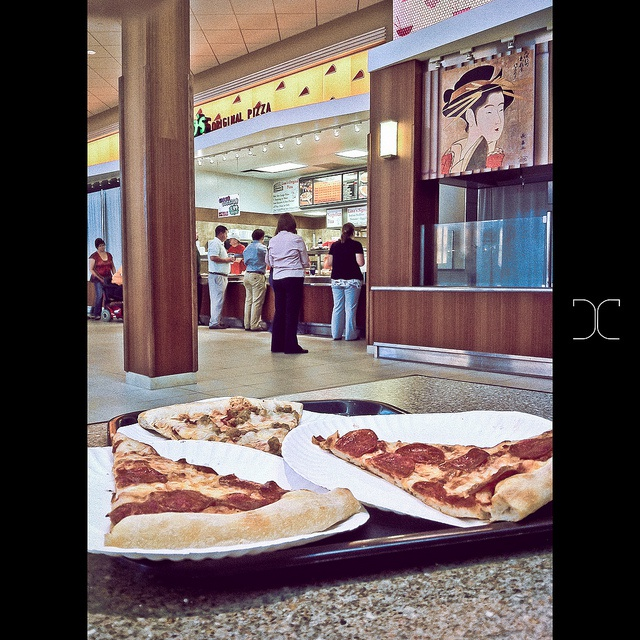Describe the objects in this image and their specific colors. I can see dining table in black, darkgray, and gray tones, pizza in black, lightgray, brown, and tan tones, pizza in black, brown, and tan tones, pizza in black, lightgray, tan, and gray tones, and people in black, darkgray, lightgray, and brown tones in this image. 